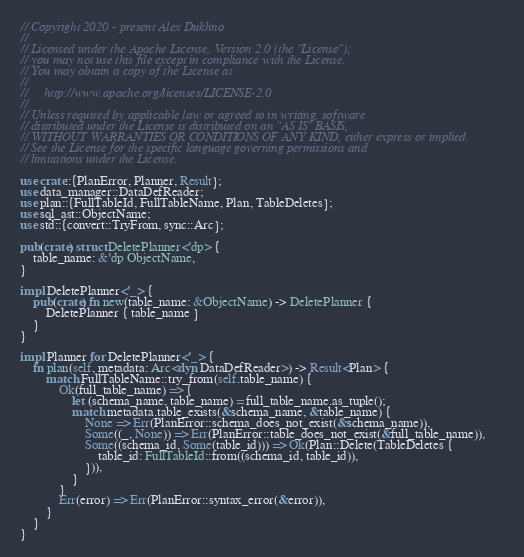Convert code to text. <code><loc_0><loc_0><loc_500><loc_500><_Rust_>// Copyright 2020 - present Alex Dukhno
//
// Licensed under the Apache License, Version 2.0 (the "License");
// you may not use this file except in compliance with the License.
// You may obtain a copy of the License at
//
//     http://www.apache.org/licenses/LICENSE-2.0
//
// Unless required by applicable law or agreed to in writing, software
// distributed under the License is distributed on an "AS IS" BASIS,
// WITHOUT WARRANTIES OR CONDITIONS OF ANY KIND, either express or implied.
// See the License for the specific language governing permissions and
// limitations under the License.

use crate::{PlanError, Planner, Result};
use data_manager::DataDefReader;
use plan::{FullTableId, FullTableName, Plan, TableDeletes};
use sql_ast::ObjectName;
use std::{convert::TryFrom, sync::Arc};

pub(crate) struct DeletePlanner<'dp> {
    table_name: &'dp ObjectName,
}

impl DeletePlanner<'_> {
    pub(crate) fn new(table_name: &ObjectName) -> DeletePlanner {
        DeletePlanner { table_name }
    }
}

impl Planner for DeletePlanner<'_> {
    fn plan(self, metadata: Arc<dyn DataDefReader>) -> Result<Plan> {
        match FullTableName::try_from(self.table_name) {
            Ok(full_table_name) => {
                let (schema_name, table_name) = full_table_name.as_tuple();
                match metadata.table_exists(&schema_name, &table_name) {
                    None => Err(PlanError::schema_does_not_exist(&schema_name)),
                    Some((_, None)) => Err(PlanError::table_does_not_exist(&full_table_name)),
                    Some((schema_id, Some(table_id))) => Ok(Plan::Delete(TableDeletes {
                        table_id: FullTableId::from((schema_id, table_id)),
                    })),
                }
            }
            Err(error) => Err(PlanError::syntax_error(&error)),
        }
    }
}
</code> 